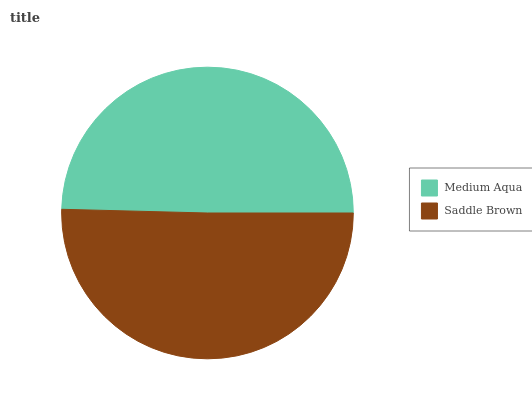Is Medium Aqua the minimum?
Answer yes or no. Yes. Is Saddle Brown the maximum?
Answer yes or no. Yes. Is Saddle Brown the minimum?
Answer yes or no. No. Is Saddle Brown greater than Medium Aqua?
Answer yes or no. Yes. Is Medium Aqua less than Saddle Brown?
Answer yes or no. Yes. Is Medium Aqua greater than Saddle Brown?
Answer yes or no. No. Is Saddle Brown less than Medium Aqua?
Answer yes or no. No. Is Saddle Brown the high median?
Answer yes or no. Yes. Is Medium Aqua the low median?
Answer yes or no. Yes. Is Medium Aqua the high median?
Answer yes or no. No. Is Saddle Brown the low median?
Answer yes or no. No. 